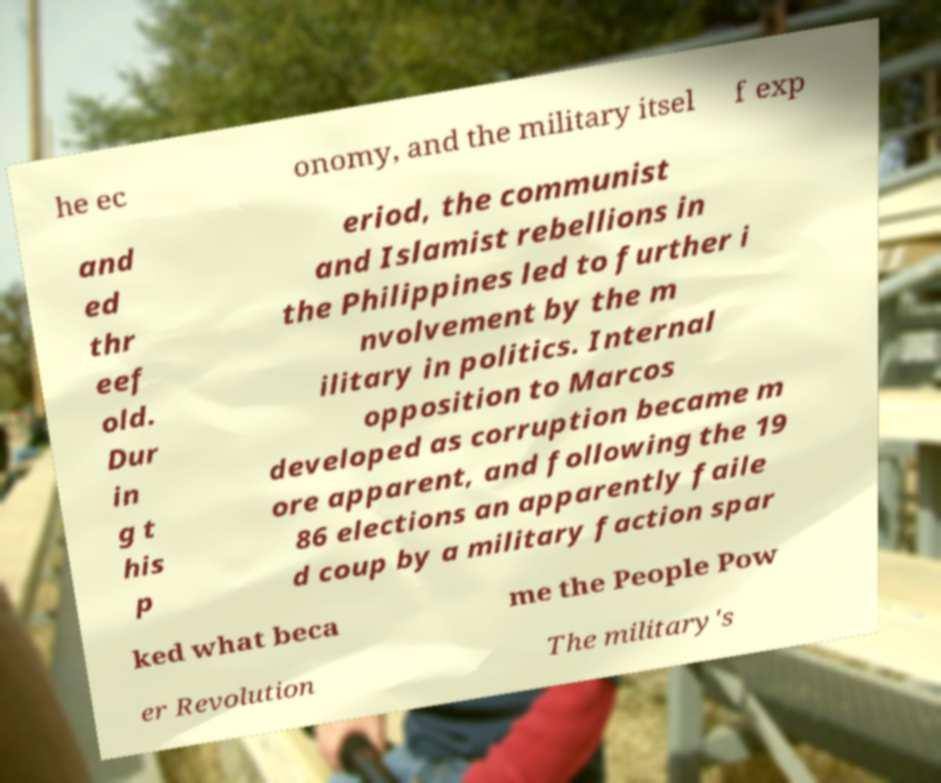Could you assist in decoding the text presented in this image and type it out clearly? he ec onomy, and the military itsel f exp and ed thr eef old. Dur in g t his p eriod, the communist and Islamist rebellions in the Philippines led to further i nvolvement by the m ilitary in politics. Internal opposition to Marcos developed as corruption became m ore apparent, and following the 19 86 elections an apparently faile d coup by a military faction spar ked what beca me the People Pow er Revolution The military's 